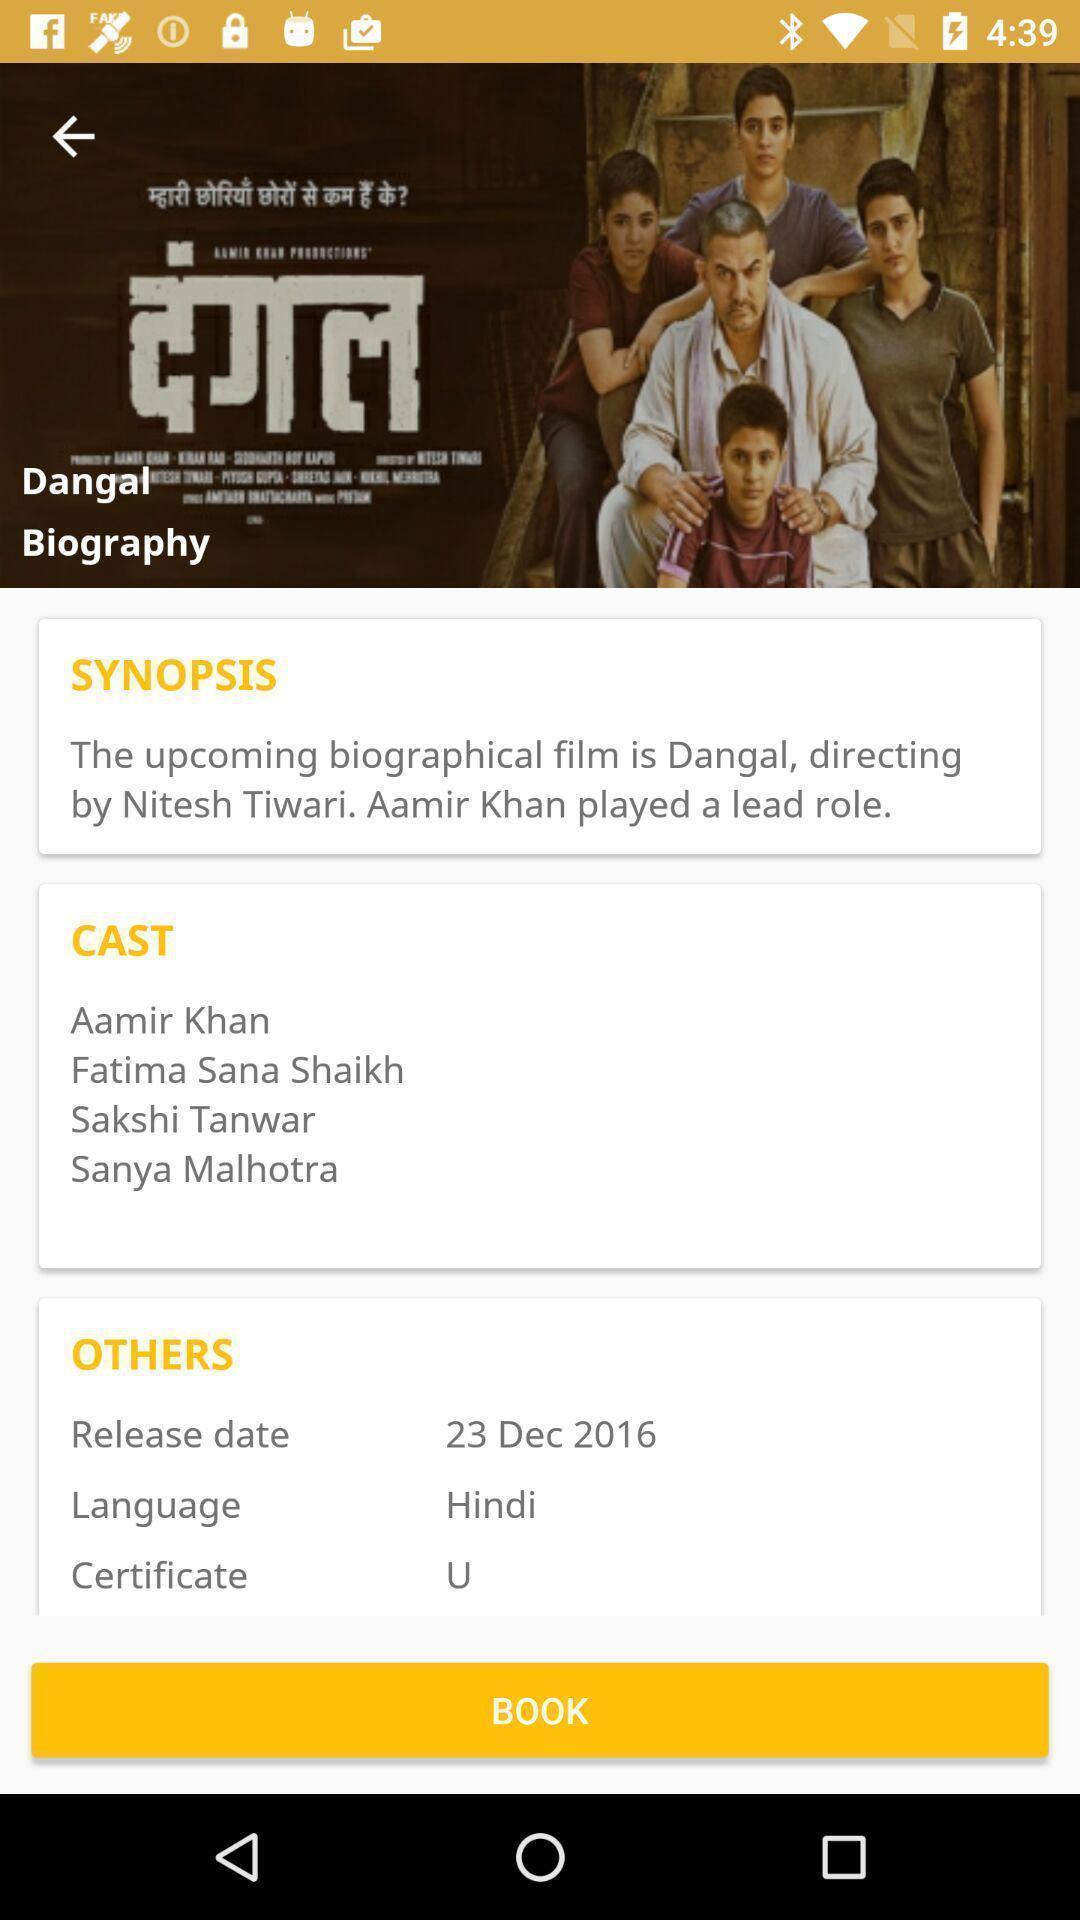Give me a summary of this screen capture. Page showing movie info in a movie theater booking app. 